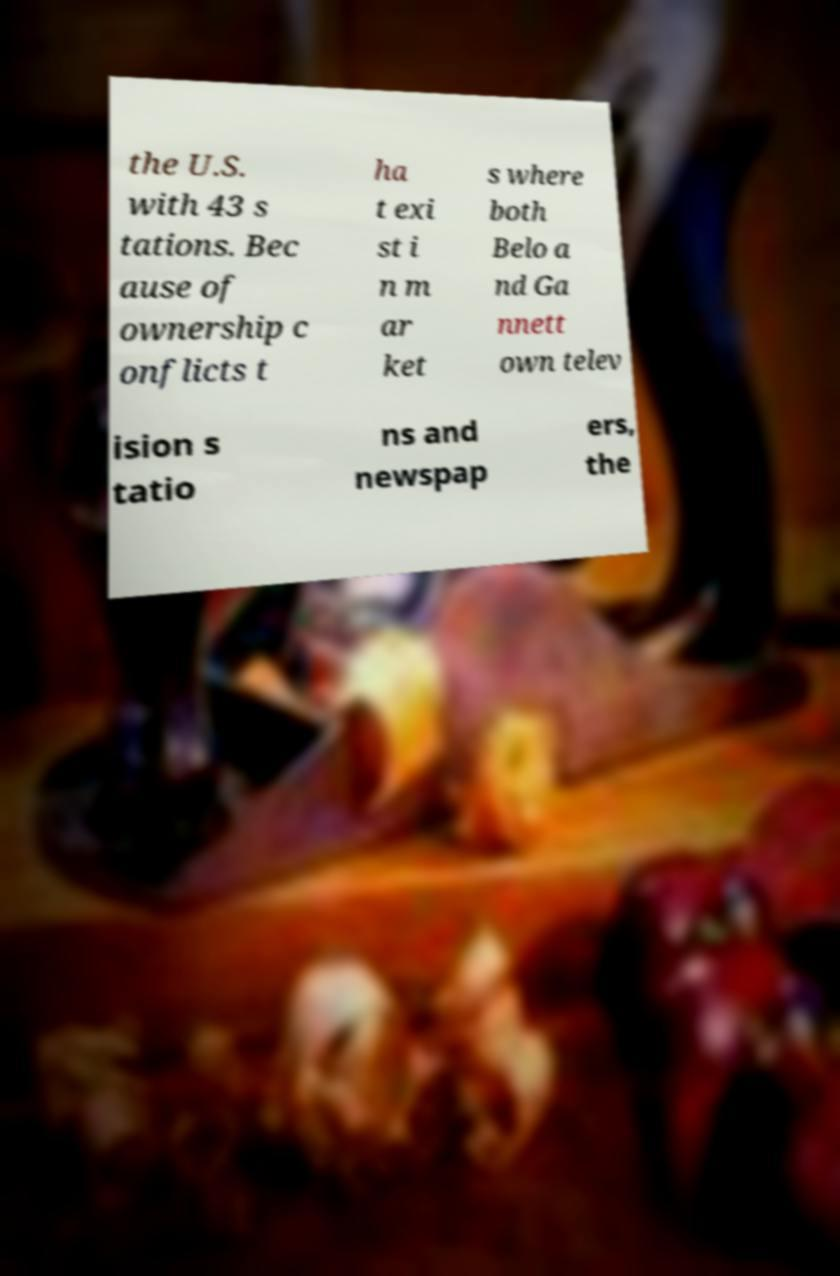For documentation purposes, I need the text within this image transcribed. Could you provide that? the U.S. with 43 s tations. Bec ause of ownership c onflicts t ha t exi st i n m ar ket s where both Belo a nd Ga nnett own telev ision s tatio ns and newspap ers, the 